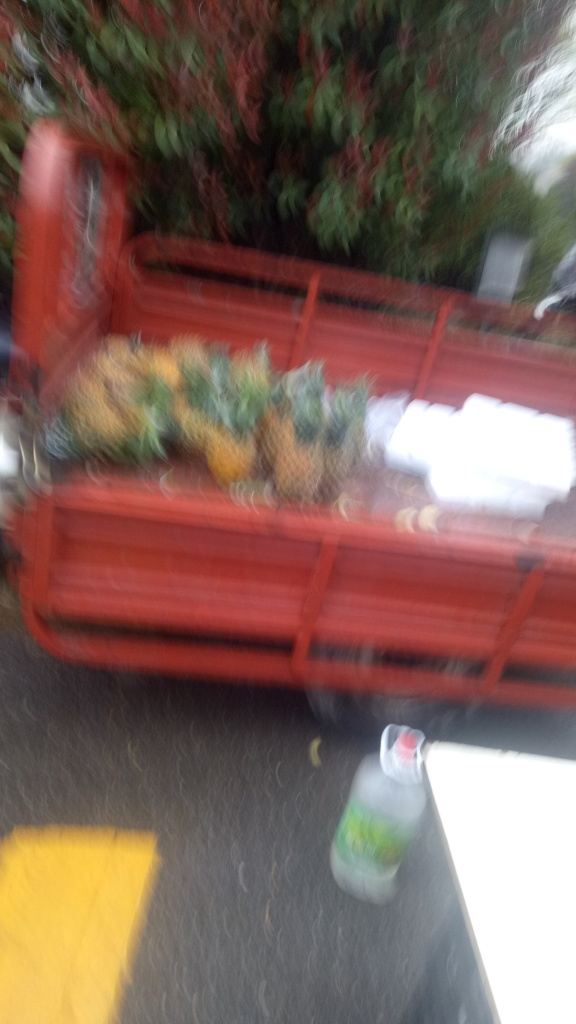Are the objects in this photo identifiable despite the blurriness? Despite the significant blur, we can still identify a red cart in the center holding what appears to be pineapples. There’s also a bottle on the ground to the left. While the specific environment and smaller details are less discernible, these larger objects remain recognizable. Could this image be improved through editing to make the background more discernible? Although editing can sometimes mitigate blurriness to a degree, this image is extremely unclear, and significant details are lost. Editing might sharpen it slightly, but the extent of the improvements would likely be limited due to the severity of the blurriness. 